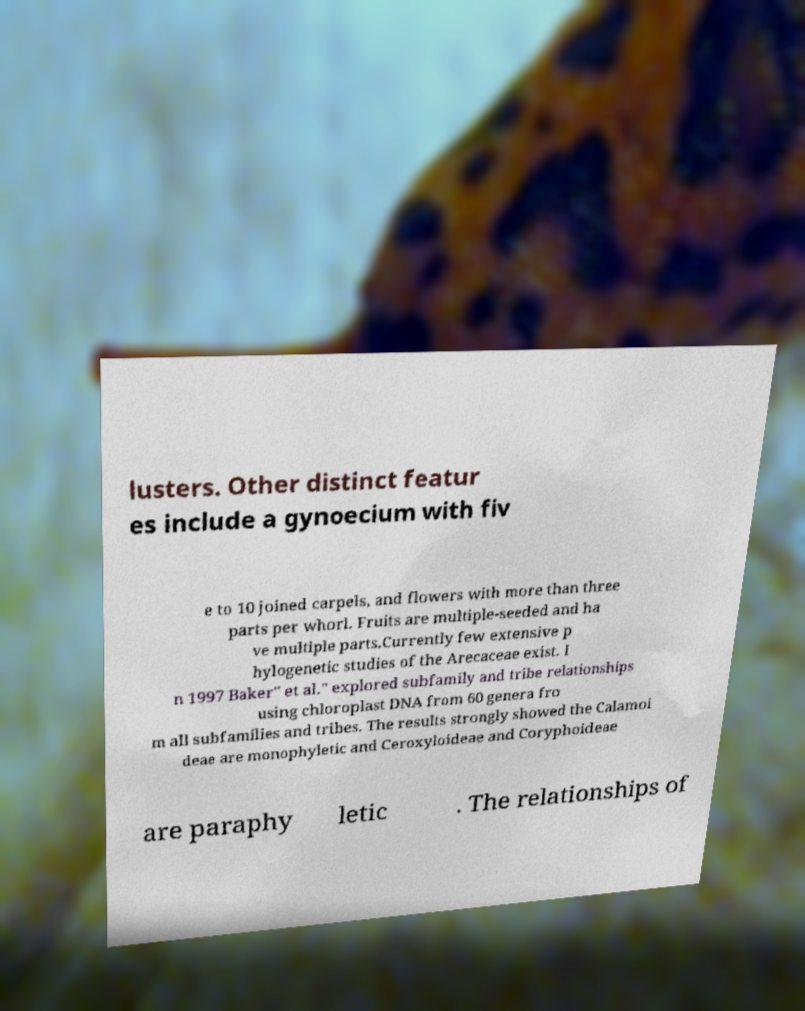For documentation purposes, I need the text within this image transcribed. Could you provide that? lusters. Other distinct featur es include a gynoecium with fiv e to 10 joined carpels, and flowers with more than three parts per whorl. Fruits are multiple-seeded and ha ve multiple parts.Currently few extensive p hylogenetic studies of the Arecaceae exist. I n 1997 Baker" et al." explored subfamily and tribe relationships using chloroplast DNA from 60 genera fro m all subfamilies and tribes. The results strongly showed the Calamoi deae are monophyletic and Ceroxyloideae and Coryphoideae are paraphy letic . The relationships of 